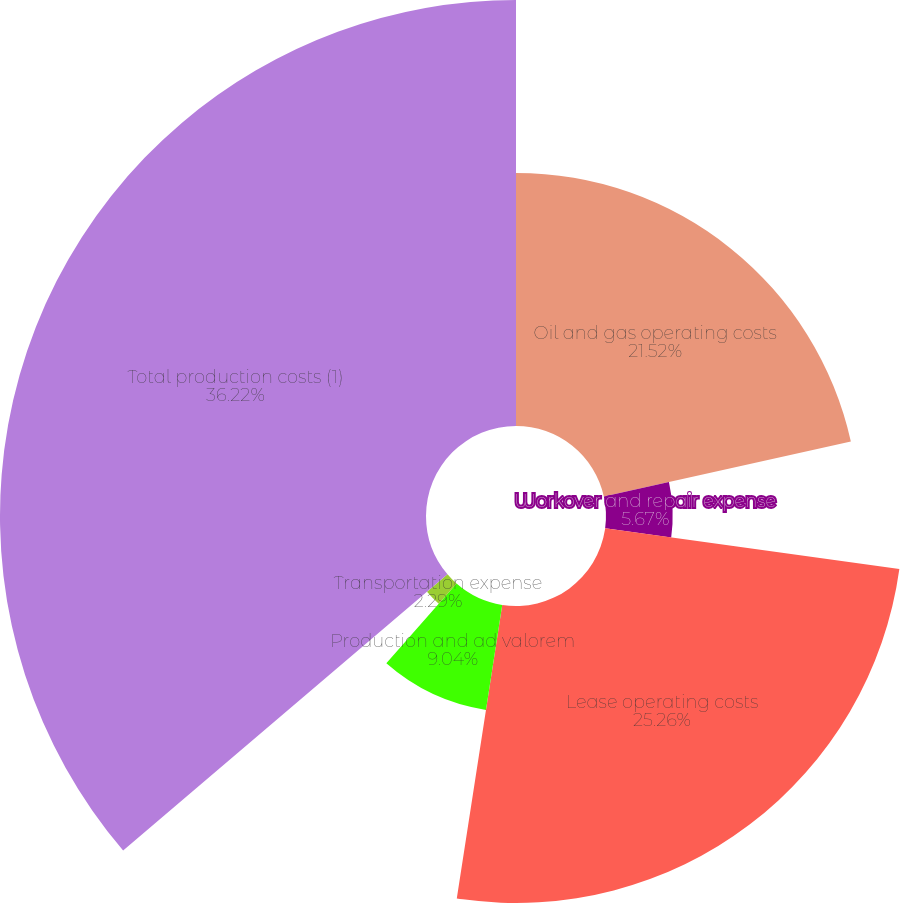Convert chart to OTSL. <chart><loc_0><loc_0><loc_500><loc_500><pie_chart><fcel>Oil and gas operating costs<fcel>Workover and repair expense<fcel>Lease operating costs<fcel>Production and ad valorem<fcel>Transportation expense<fcel>Total production costs (1)<nl><fcel>21.52%<fcel>5.67%<fcel>25.26%<fcel>9.04%<fcel>2.29%<fcel>36.23%<nl></chart> 